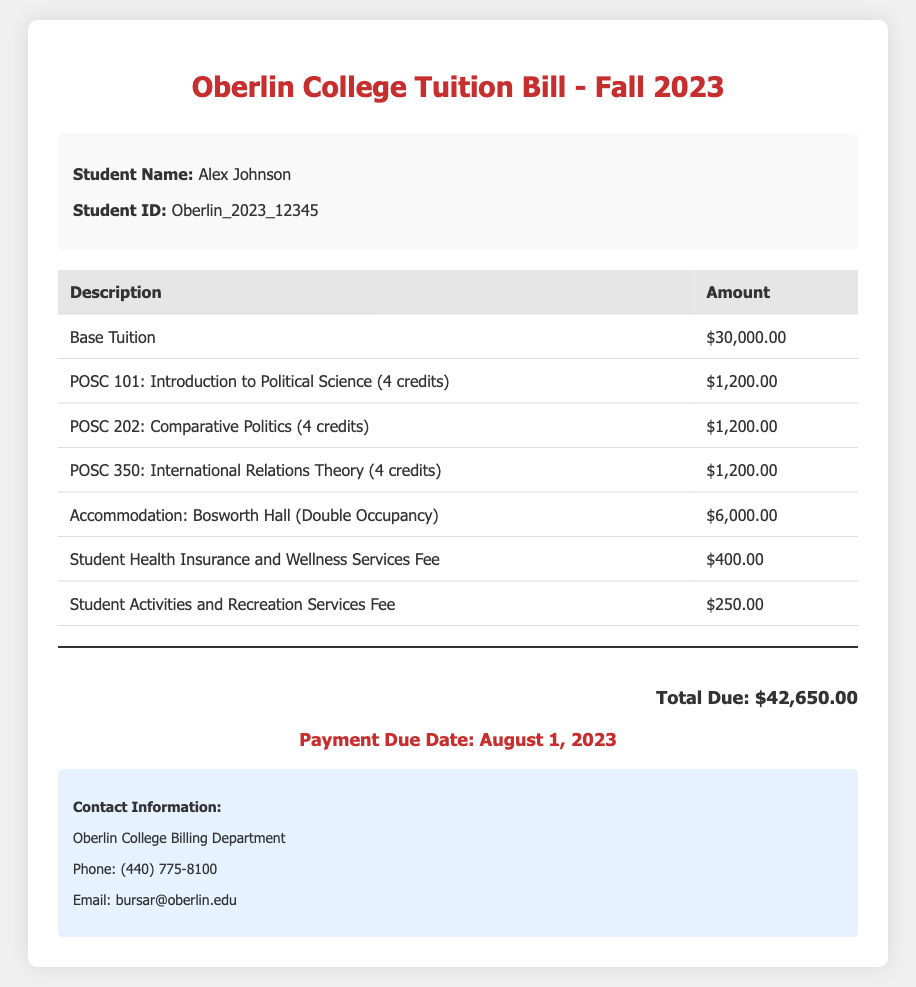What is the name of the student? The student's name is provided in the document and is listed as Alex Johnson.
Answer: Alex Johnson What is the total amount due? The total due amount is calculated by summing all fees listed in the table, which equals $42,650.00.
Answer: $42,650.00 When is the payment due date? The due date for payment is specified in the document as August 1, 2023.
Answer: August 1, 2023 How much is the accommodation fee for Bosworth Hall? The accommodation fee for Bosworth Hall (Double Occupancy) is directly stated in the document.
Answer: $6,000.00 How many credits is the course POSC 350? The number of credits for POSC 350: International Relations Theory is given in the document as 4 credits.
Answer: 4 credits What is the fee for student health insurance? The document specifies the fee for student health insurance and wellness services as $400.00.
Answer: $400.00 Who should be contacted for billing inquiries? The contact information for billing inquiries is included in the document. The responsible department is the Oberlin College Billing Department.
Answer: Oberlin College Billing Department What is the tuition fee for POSC 202? The tuition fee for the course POSC 202: Comparative Politics is provided in the document.
Answer: $1,200.00 What is the purpose of the student activities and recreation services fee? The document defines this fee as for student activities and recreation services, relating to student engagement and leisure.
Answer: Student Activities and Recreation Services Fee 